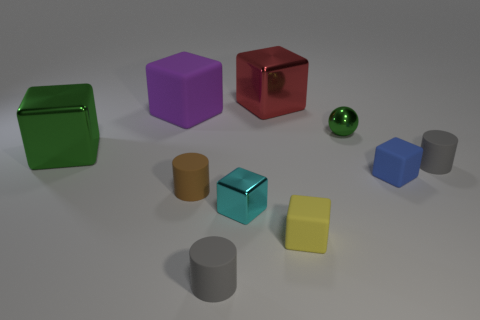Subtract all brown rubber cylinders. How many cylinders are left? 2 Subtract all spheres. How many objects are left? 9 Subtract 2 blocks. How many blocks are left? 4 Subtract all green spheres. How many gray cubes are left? 0 Subtract all large shiny cubes. Subtract all big cyan matte blocks. How many objects are left? 8 Add 9 blue cubes. How many blue cubes are left? 10 Add 7 tiny blue matte cylinders. How many tiny blue matte cylinders exist? 7 Subtract all gray cylinders. How many cylinders are left? 1 Subtract 1 cyan blocks. How many objects are left? 9 Subtract all gray cylinders. Subtract all green spheres. How many cylinders are left? 1 